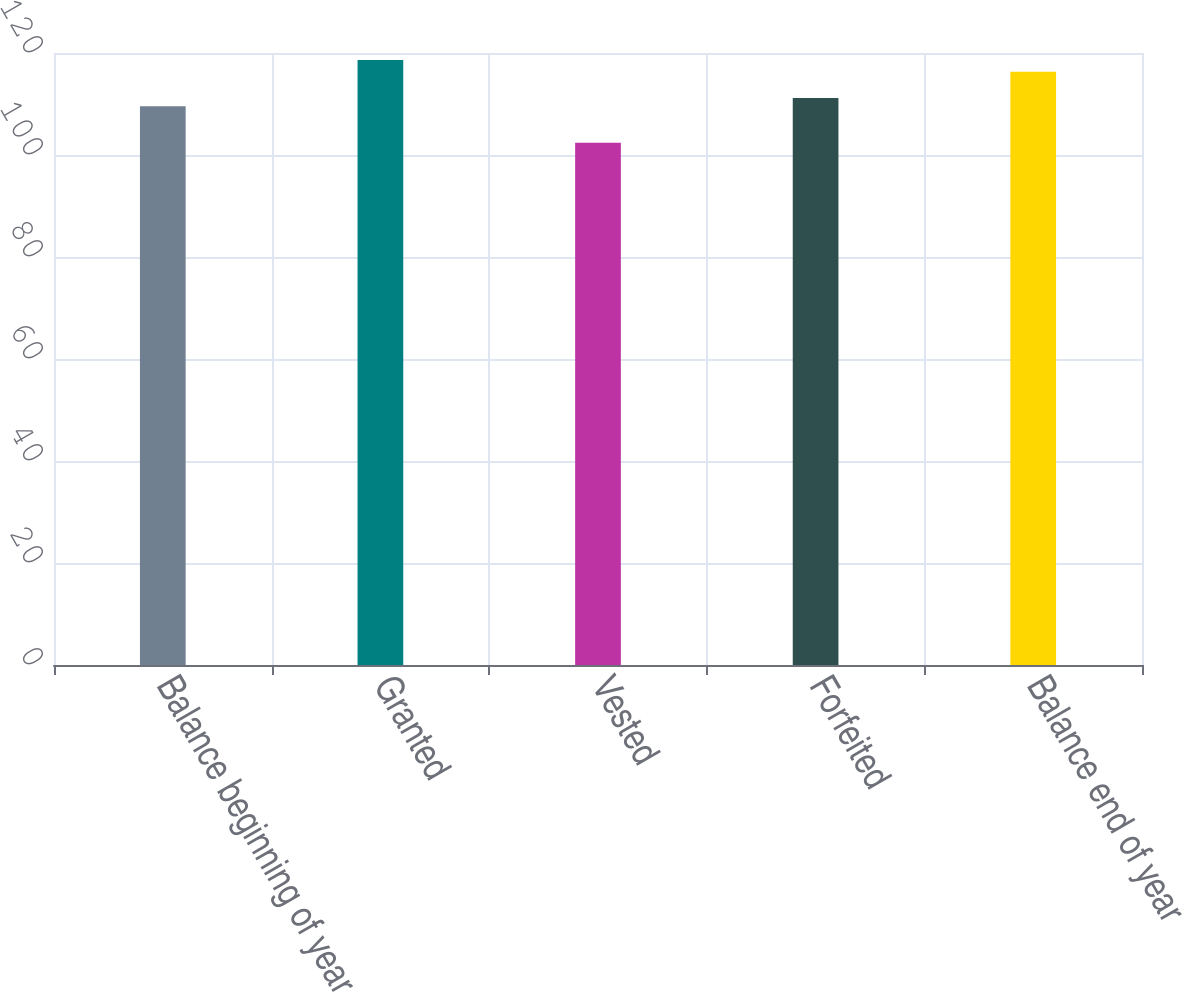<chart> <loc_0><loc_0><loc_500><loc_500><bar_chart><fcel>Balance beginning of year<fcel>Granted<fcel>Vested<fcel>Forfeited<fcel>Balance end of year<nl><fcel>109.54<fcel>118.63<fcel>102.4<fcel>111.16<fcel>116.32<nl></chart> 